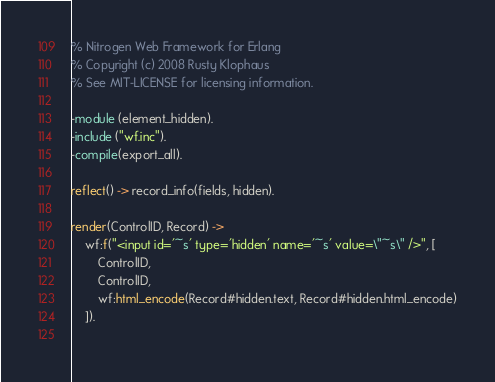Convert code to text. <code><loc_0><loc_0><loc_500><loc_500><_Erlang_>% Nitrogen Web Framework for Erlang
% Copyright (c) 2008 Rusty Klophaus
% See MIT-LICENSE for licensing information.

-module (element_hidden).
-include ("wf.inc").
-compile(export_all).

reflect() -> record_info(fields, hidden).

render(ControlID, Record) -> 
	wf:f("<input id='~s' type='hidden' name='~s' value=\"~s\" />", [
		ControlID, 
		ControlID, 
		wf:html_encode(Record#hidden.text, Record#hidden.html_encode)
	]).
	
</code> 